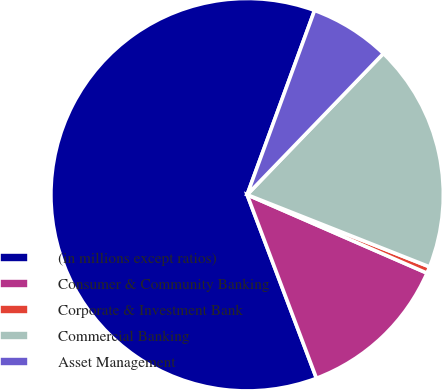<chart> <loc_0><loc_0><loc_500><loc_500><pie_chart><fcel>(in millions except ratios)<fcel>Consumer & Community Banking<fcel>Corporate & Investment Bank<fcel>Commercial Banking<fcel>Asset Management<nl><fcel>61.33%<fcel>12.71%<fcel>0.55%<fcel>18.78%<fcel>6.63%<nl></chart> 